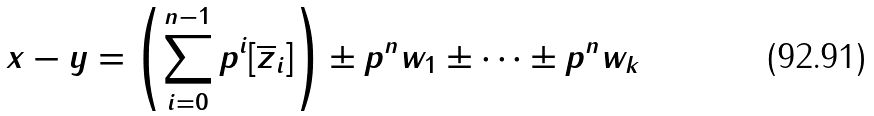Convert formula to latex. <formula><loc_0><loc_0><loc_500><loc_500>x - y = \left ( \sum _ { i = 0 } ^ { n - 1 } p ^ { i } [ \overline { z } _ { i } ] \right ) \pm p ^ { n } w _ { 1 } \pm \cdots \pm p ^ { n } w _ { k }</formula> 